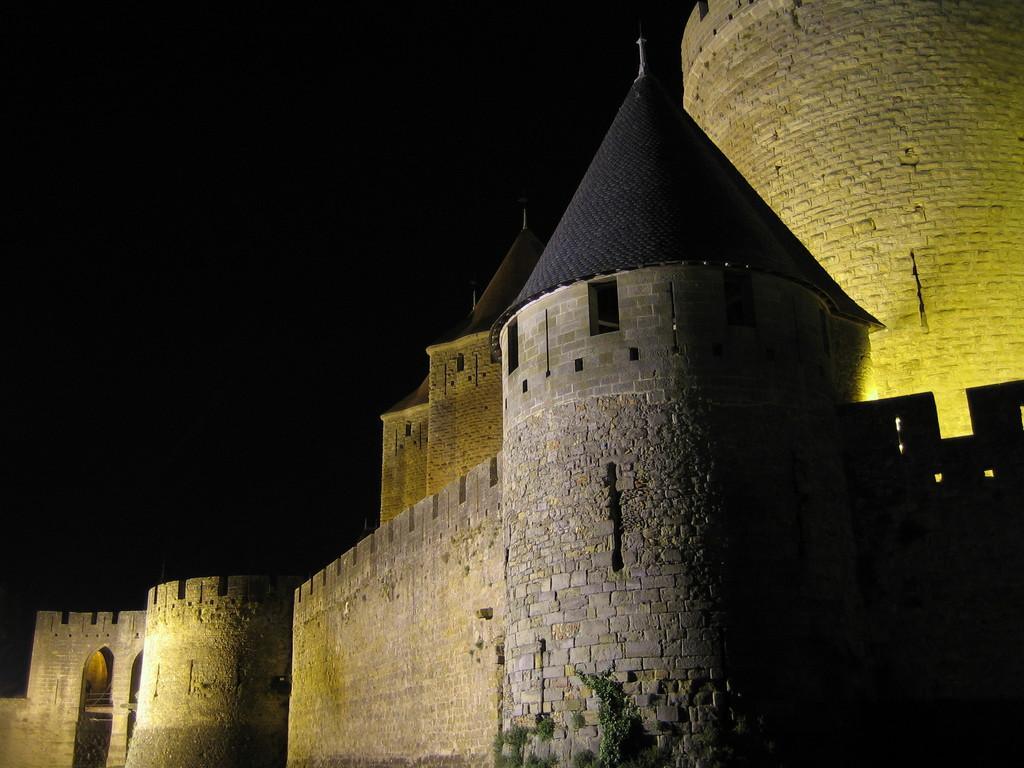How would you summarize this image in a sentence or two? In this image, we can see castle on the dark background. 